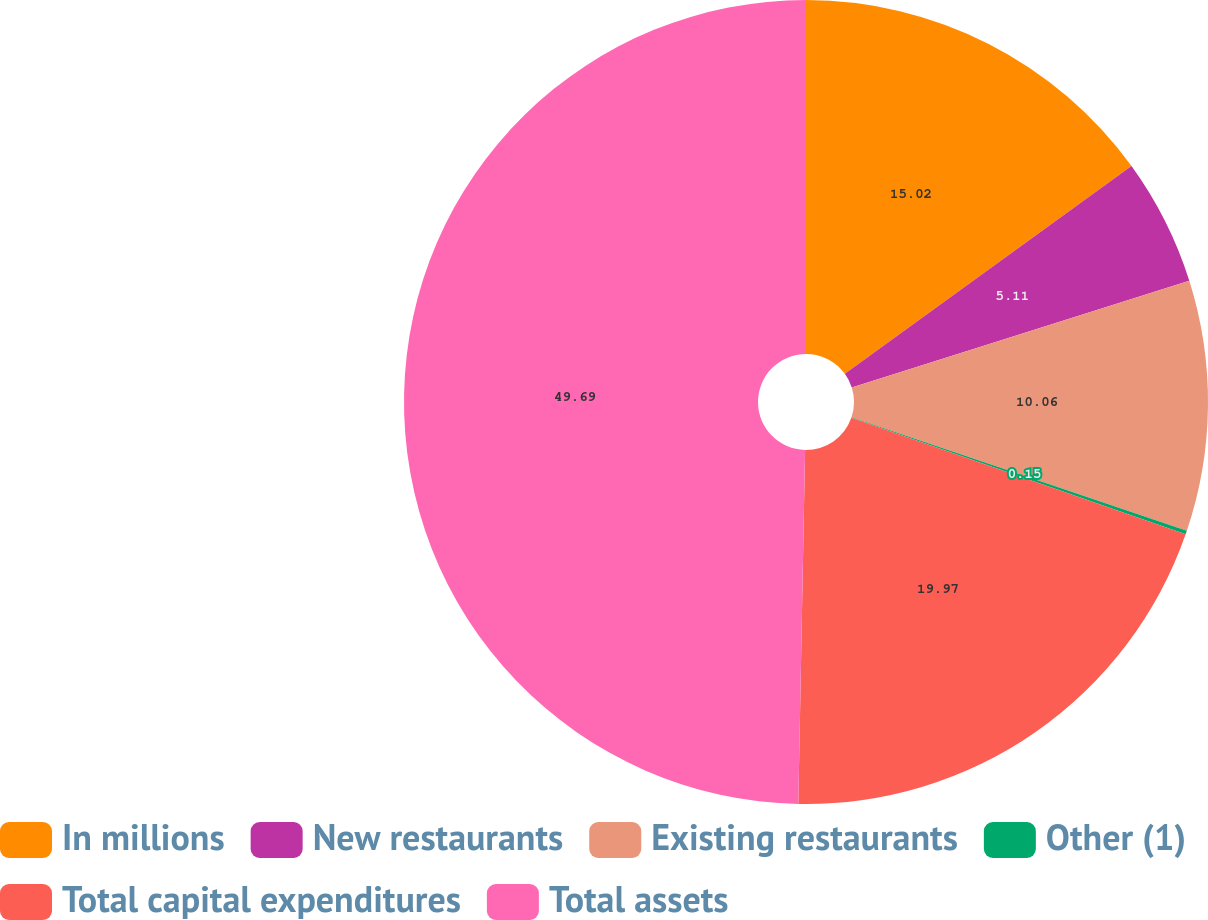Convert chart to OTSL. <chart><loc_0><loc_0><loc_500><loc_500><pie_chart><fcel>In millions<fcel>New restaurants<fcel>Existing restaurants<fcel>Other (1)<fcel>Total capital expenditures<fcel>Total assets<nl><fcel>15.02%<fcel>5.11%<fcel>10.06%<fcel>0.15%<fcel>19.97%<fcel>49.7%<nl></chart> 